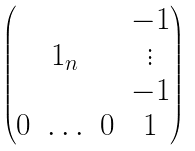<formula> <loc_0><loc_0><loc_500><loc_500>\begin{pmatrix} & & & - 1 \\ & { 1 } _ { n } & & \vdots \\ & & & - 1 \\ 0 & \hdots & 0 & 1 \end{pmatrix}</formula> 